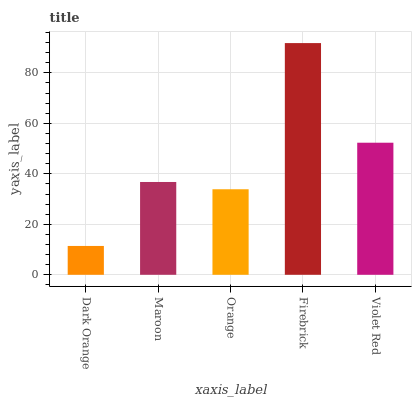Is Dark Orange the minimum?
Answer yes or no. Yes. Is Firebrick the maximum?
Answer yes or no. Yes. Is Maroon the minimum?
Answer yes or no. No. Is Maroon the maximum?
Answer yes or no. No. Is Maroon greater than Dark Orange?
Answer yes or no. Yes. Is Dark Orange less than Maroon?
Answer yes or no. Yes. Is Dark Orange greater than Maroon?
Answer yes or no. No. Is Maroon less than Dark Orange?
Answer yes or no. No. Is Maroon the high median?
Answer yes or no. Yes. Is Maroon the low median?
Answer yes or no. Yes. Is Firebrick the high median?
Answer yes or no. No. Is Violet Red the low median?
Answer yes or no. No. 